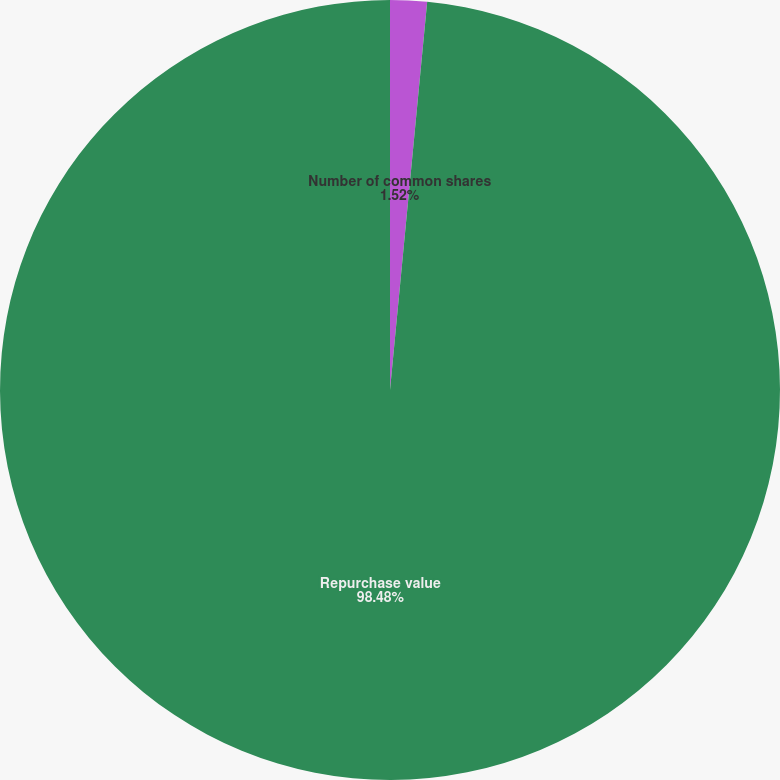<chart> <loc_0><loc_0><loc_500><loc_500><pie_chart><fcel>Number of common shares<fcel>Repurchase value<nl><fcel>1.52%<fcel>98.48%<nl></chart> 